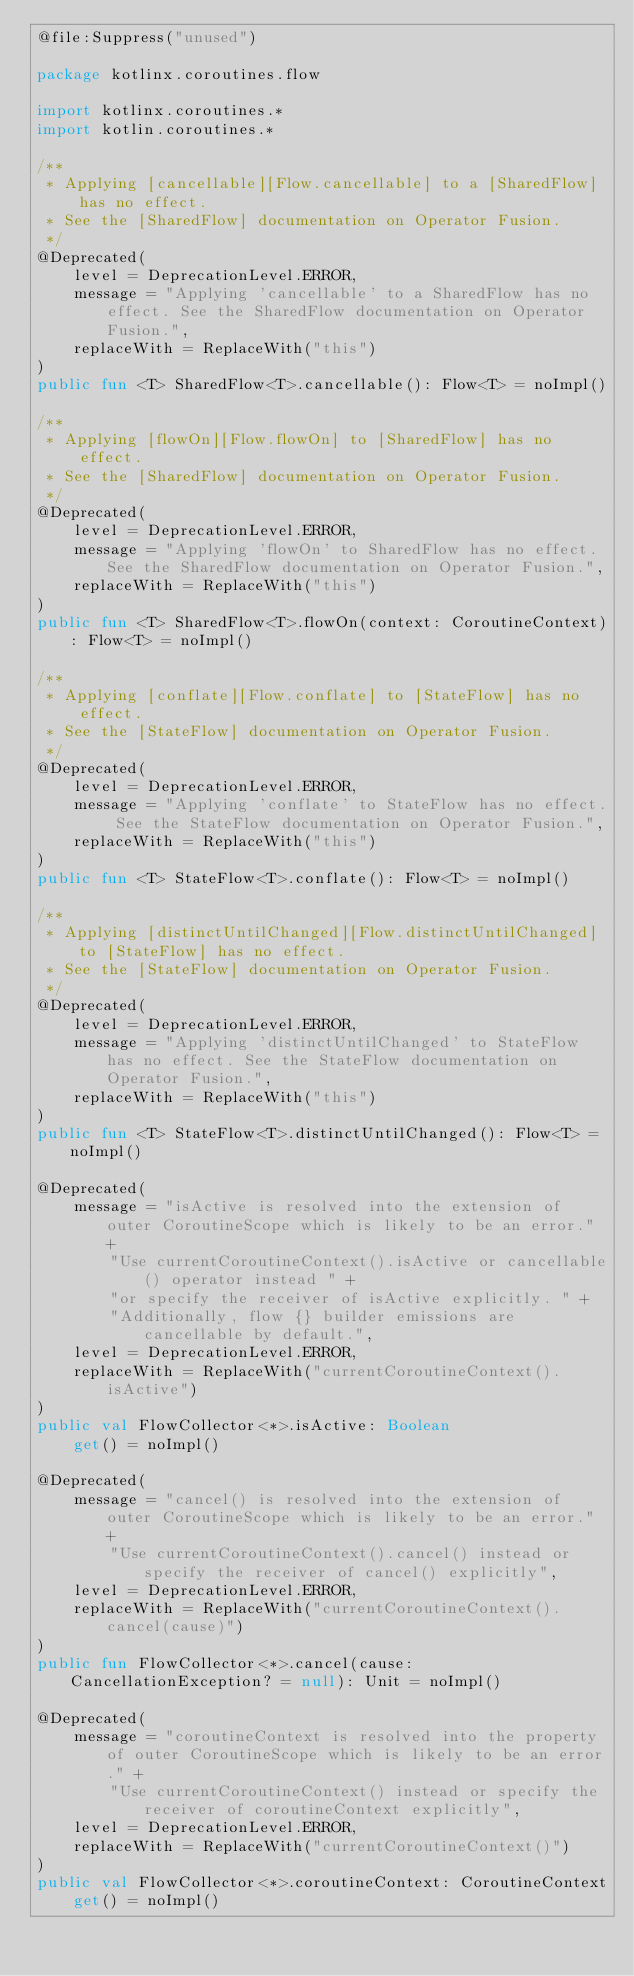Convert code to text. <code><loc_0><loc_0><loc_500><loc_500><_Kotlin_>@file:Suppress("unused")

package kotlinx.coroutines.flow

import kotlinx.coroutines.*
import kotlin.coroutines.*

/**
 * Applying [cancellable][Flow.cancellable] to a [SharedFlow] has no effect.
 * See the [SharedFlow] documentation on Operator Fusion.
 */
@Deprecated(
    level = DeprecationLevel.ERROR,
    message = "Applying 'cancellable' to a SharedFlow has no effect. See the SharedFlow documentation on Operator Fusion.",
    replaceWith = ReplaceWith("this")
)
public fun <T> SharedFlow<T>.cancellable(): Flow<T> = noImpl()

/**
 * Applying [flowOn][Flow.flowOn] to [SharedFlow] has no effect.
 * See the [SharedFlow] documentation on Operator Fusion.
 */
@Deprecated(
    level = DeprecationLevel.ERROR,
    message = "Applying 'flowOn' to SharedFlow has no effect. See the SharedFlow documentation on Operator Fusion.",
    replaceWith = ReplaceWith("this")
)
public fun <T> SharedFlow<T>.flowOn(context: CoroutineContext): Flow<T> = noImpl()

/**
 * Applying [conflate][Flow.conflate] to [StateFlow] has no effect.
 * See the [StateFlow] documentation on Operator Fusion.
 */
@Deprecated(
    level = DeprecationLevel.ERROR,
    message = "Applying 'conflate' to StateFlow has no effect. See the StateFlow documentation on Operator Fusion.",
    replaceWith = ReplaceWith("this")
)
public fun <T> StateFlow<T>.conflate(): Flow<T> = noImpl()

/**
 * Applying [distinctUntilChanged][Flow.distinctUntilChanged] to [StateFlow] has no effect.
 * See the [StateFlow] documentation on Operator Fusion.
 */
@Deprecated(
    level = DeprecationLevel.ERROR,
    message = "Applying 'distinctUntilChanged' to StateFlow has no effect. See the StateFlow documentation on Operator Fusion.",
    replaceWith = ReplaceWith("this")
)
public fun <T> StateFlow<T>.distinctUntilChanged(): Flow<T> = noImpl()

@Deprecated(
    message = "isActive is resolved into the extension of outer CoroutineScope which is likely to be an error." +
        "Use currentCoroutineContext().isActive or cancellable() operator instead " +
        "or specify the receiver of isActive explicitly. " +
        "Additionally, flow {} builder emissions are cancellable by default.",
    level = DeprecationLevel.ERROR,
    replaceWith = ReplaceWith("currentCoroutineContext().isActive")
)
public val FlowCollector<*>.isActive: Boolean
    get() = noImpl()

@Deprecated(
    message = "cancel() is resolved into the extension of outer CoroutineScope which is likely to be an error." +
        "Use currentCoroutineContext().cancel() instead or specify the receiver of cancel() explicitly",
    level = DeprecationLevel.ERROR,
    replaceWith = ReplaceWith("currentCoroutineContext().cancel(cause)")
)
public fun FlowCollector<*>.cancel(cause: CancellationException? = null): Unit = noImpl()

@Deprecated(
    message = "coroutineContext is resolved into the property of outer CoroutineScope which is likely to be an error." +
        "Use currentCoroutineContext() instead or specify the receiver of coroutineContext explicitly",
    level = DeprecationLevel.ERROR,
    replaceWith = ReplaceWith("currentCoroutineContext()")
)
public val FlowCollector<*>.coroutineContext: CoroutineContext
    get() = noImpl()</code> 